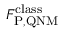Convert formula to latex. <formula><loc_0><loc_0><loc_500><loc_500>F _ { P , Q N M } ^ { c l a s s }</formula> 